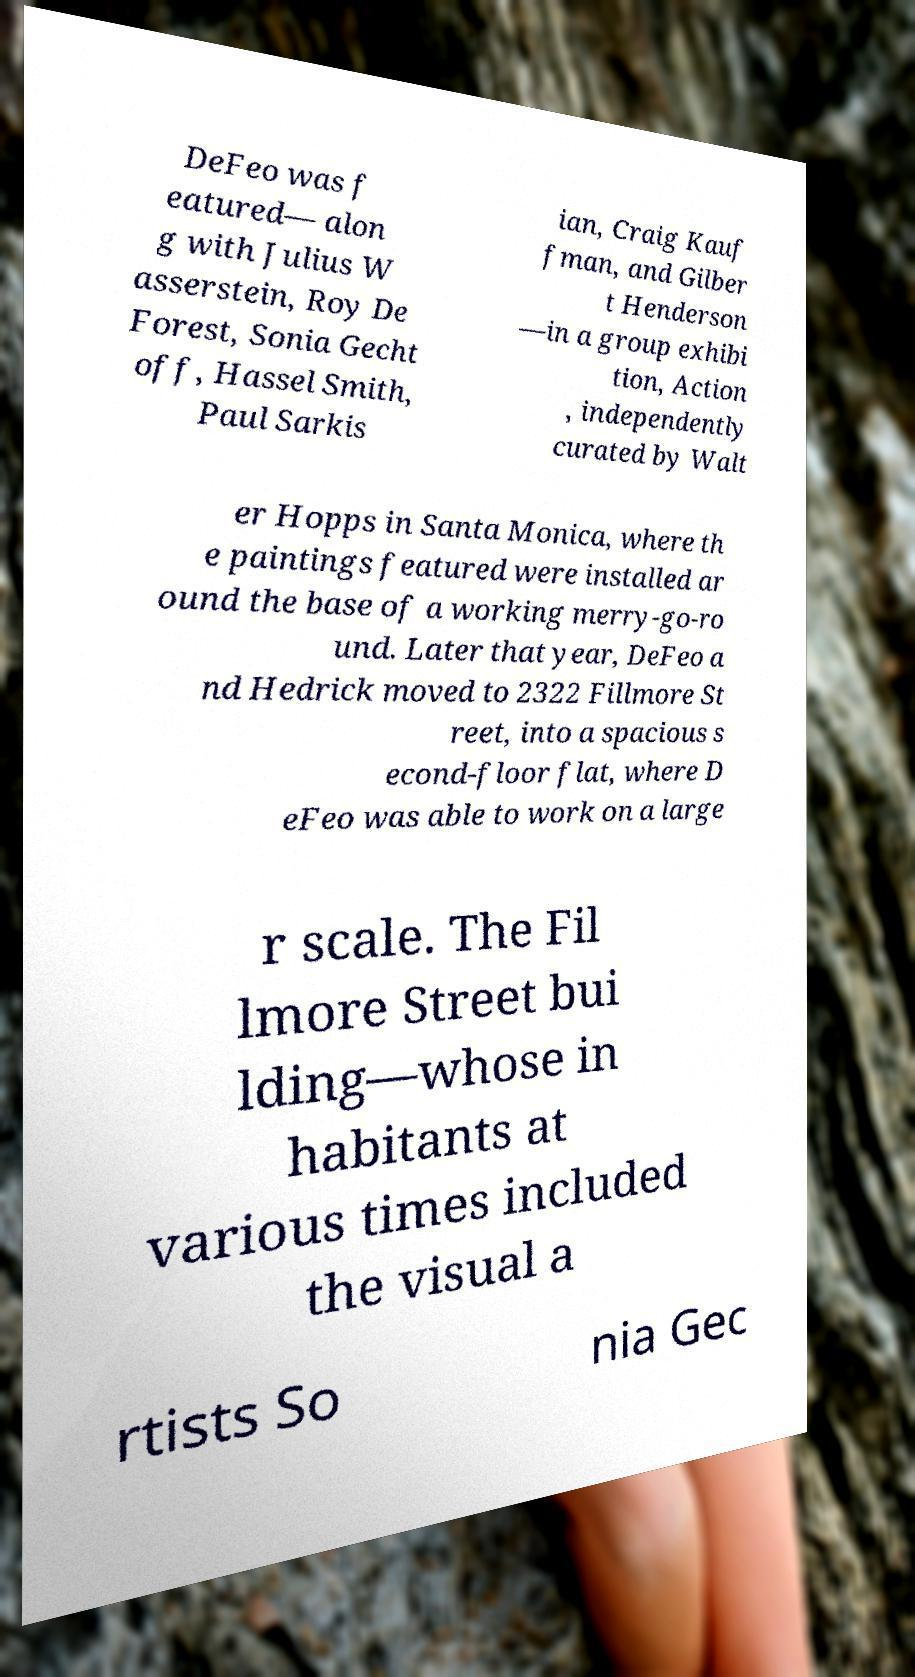Could you extract and type out the text from this image? DeFeo was f eatured— alon g with Julius W asserstein, Roy De Forest, Sonia Gecht off, Hassel Smith, Paul Sarkis ian, Craig Kauf fman, and Gilber t Henderson —in a group exhibi tion, Action , independently curated by Walt er Hopps in Santa Monica, where th e paintings featured were installed ar ound the base of a working merry-go-ro und. Later that year, DeFeo a nd Hedrick moved to 2322 Fillmore St reet, into a spacious s econd-floor flat, where D eFeo was able to work on a large r scale. The Fil lmore Street bui lding—whose in habitants at various times included the visual a rtists So nia Gec 